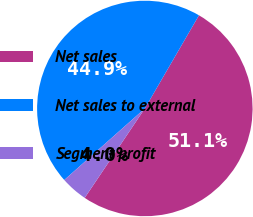Convert chart to OTSL. <chart><loc_0><loc_0><loc_500><loc_500><pie_chart><fcel>Net sales<fcel>Net sales to external<fcel>Segment profit<nl><fcel>51.05%<fcel>44.93%<fcel>4.02%<nl></chart> 